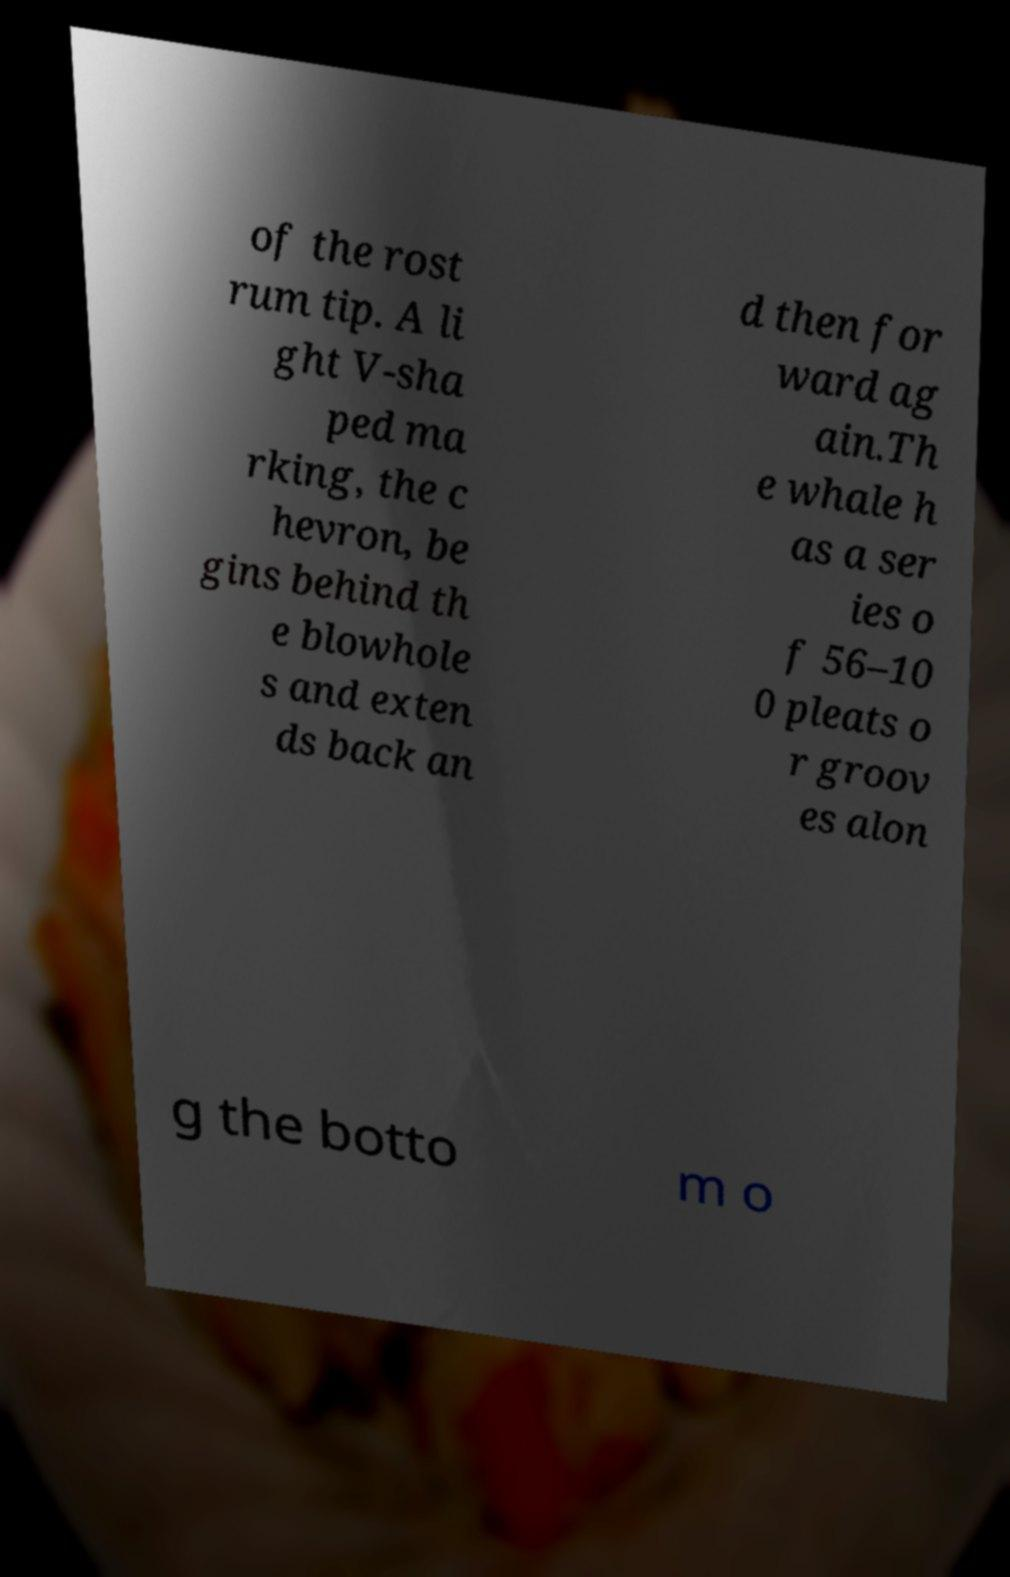Can you read and provide the text displayed in the image?This photo seems to have some interesting text. Can you extract and type it out for me? of the rost rum tip. A li ght V-sha ped ma rking, the c hevron, be gins behind th e blowhole s and exten ds back an d then for ward ag ain.Th e whale h as a ser ies o f 56–10 0 pleats o r groov es alon g the botto m o 